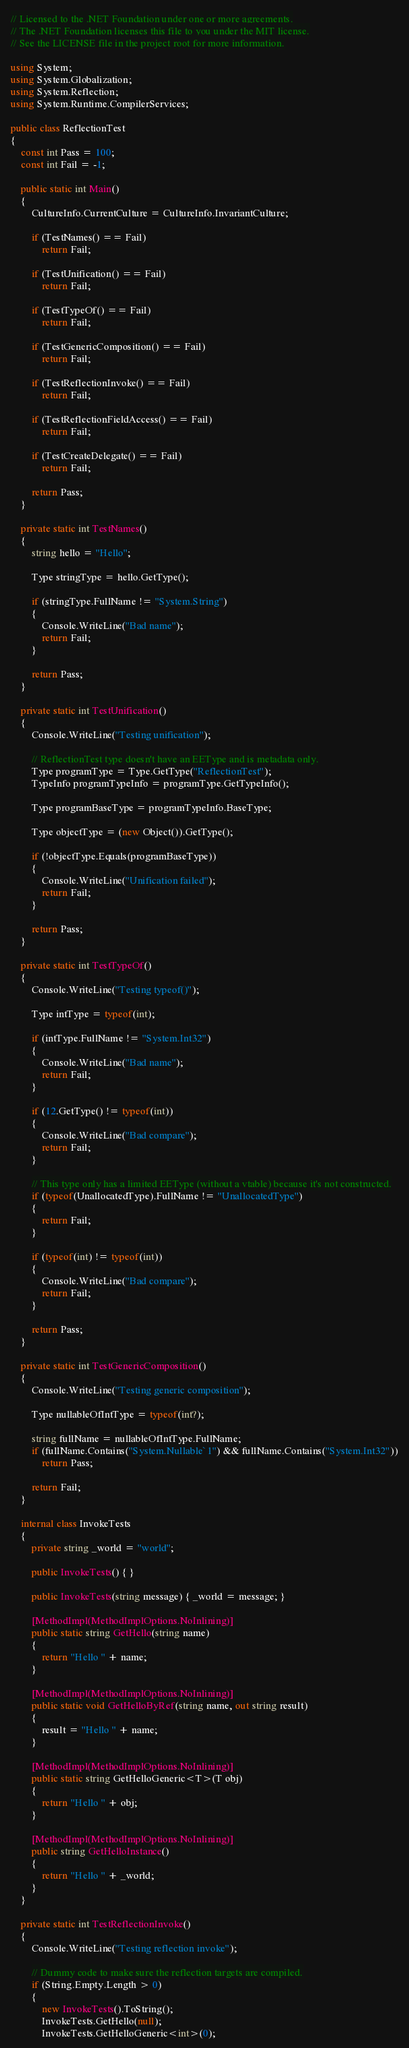Convert code to text. <code><loc_0><loc_0><loc_500><loc_500><_C#_>// Licensed to the .NET Foundation under one or more agreements.
// The .NET Foundation licenses this file to you under the MIT license.
// See the LICENSE file in the project root for more information.

using System;
using System.Globalization;
using System.Reflection;
using System.Runtime.CompilerServices;

public class ReflectionTest
{
    const int Pass = 100;
    const int Fail = -1;

    public static int Main()
    {
        CultureInfo.CurrentCulture = CultureInfo.InvariantCulture;

        if (TestNames() == Fail)
            return Fail;

        if (TestUnification() == Fail)
            return Fail;

        if (TestTypeOf() == Fail)
            return Fail;

        if (TestGenericComposition() == Fail)
            return Fail;

        if (TestReflectionInvoke() == Fail)
            return Fail;

        if (TestReflectionFieldAccess() == Fail)
            return Fail;

        if (TestCreateDelegate() == Fail)
            return Fail;

        return Pass;
    }

    private static int TestNames()
    {
        string hello = "Hello";

        Type stringType = hello.GetType();

        if (stringType.FullName != "System.String")
        {
            Console.WriteLine("Bad name");
            return Fail;
        }

        return Pass;
    }

    private static int TestUnification()
    {
        Console.WriteLine("Testing unification");

        // ReflectionTest type doesn't have an EEType and is metadata only.
        Type programType = Type.GetType("ReflectionTest");
        TypeInfo programTypeInfo = programType.GetTypeInfo();

        Type programBaseType = programTypeInfo.BaseType;

        Type objectType = (new Object()).GetType();

        if (!objectType.Equals(programBaseType))
        {
            Console.WriteLine("Unification failed");
            return Fail;
        }

        return Pass;
    }

    private static int TestTypeOf()
    {
        Console.WriteLine("Testing typeof()");

        Type intType = typeof(int);

        if (intType.FullName != "System.Int32")
        {
            Console.WriteLine("Bad name");
            return Fail;
        }

        if (12.GetType() != typeof(int))
        {
            Console.WriteLine("Bad compare");
            return Fail;
        }

        // This type only has a limited EEType (without a vtable) because it's not constructed.
        if (typeof(UnallocatedType).FullName != "UnallocatedType")
        {
            return Fail;
        }

        if (typeof(int) != typeof(int))
        {
            Console.WriteLine("Bad compare");
            return Fail;
        }

        return Pass;
    }

    private static int TestGenericComposition()
    {
        Console.WriteLine("Testing generic composition");

        Type nullableOfIntType = typeof(int?);

        string fullName = nullableOfIntType.FullName;
        if (fullName.Contains("System.Nullable`1") && fullName.Contains("System.Int32"))
            return Pass;

        return Fail;
    }

    internal class InvokeTests
    {
        private string _world = "world";

        public InvokeTests() { }

        public InvokeTests(string message) { _world = message; }

        [MethodImpl(MethodImplOptions.NoInlining)]
        public static string GetHello(string name)
        {
            return "Hello " + name;
        }

        [MethodImpl(MethodImplOptions.NoInlining)]
        public static void GetHelloByRef(string name, out string result)
        {
            result = "Hello " + name;
        }

        [MethodImpl(MethodImplOptions.NoInlining)]
        public static string GetHelloGeneric<T>(T obj)
        {
            return "Hello " + obj;
        }

        [MethodImpl(MethodImplOptions.NoInlining)]
        public string GetHelloInstance()
        {
            return "Hello " + _world;
        }
    }

    private static int TestReflectionInvoke()
    {
        Console.WriteLine("Testing reflection invoke");

        // Dummy code to make sure the reflection targets are compiled.
        if (String.Empty.Length > 0)
        {
            new InvokeTests().ToString();
            InvokeTests.GetHello(null);
            InvokeTests.GetHelloGeneric<int>(0);</code> 